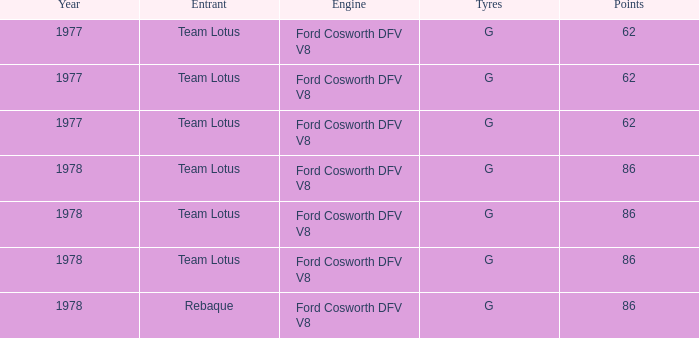What is the emphasis that has a year exceeding 1977? 86, 86, 86, 86. 